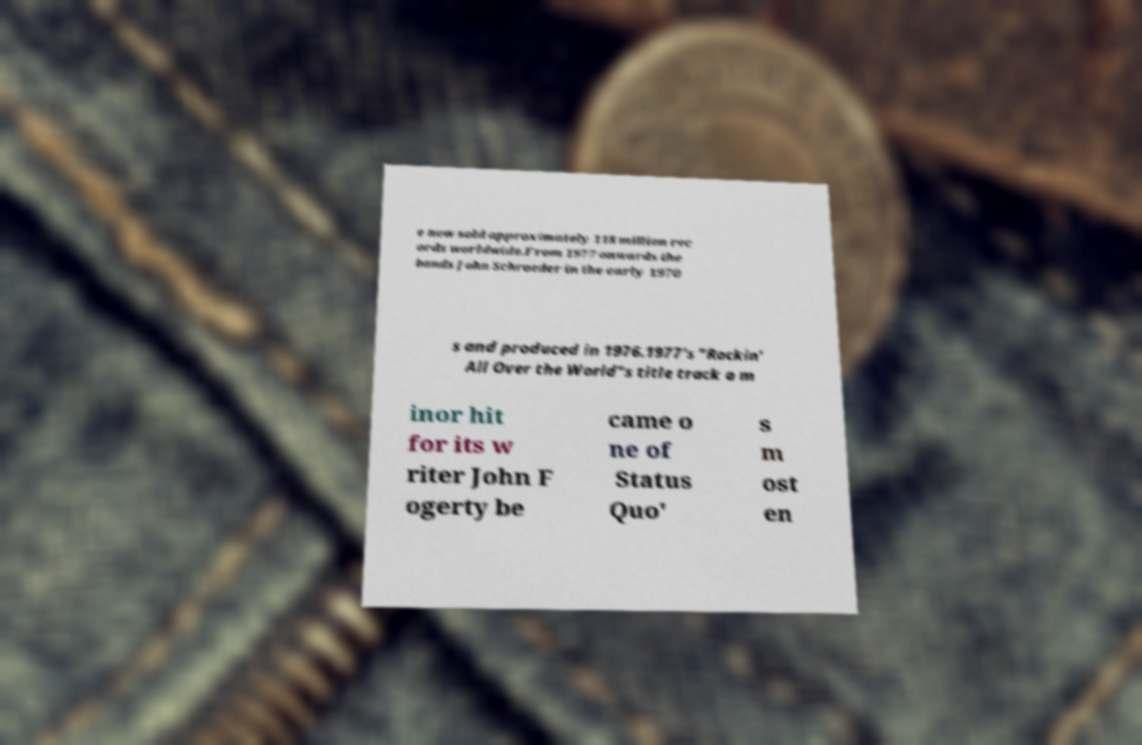Could you extract and type out the text from this image? e now sold approximately 118 million rec ords worldwide.From 1977 onwards the bands John Schroeder in the early 1970 s and produced in 1976.1977's "Rockin' All Over the World"s title track a m inor hit for its w riter John F ogerty be came o ne of Status Quo' s m ost en 